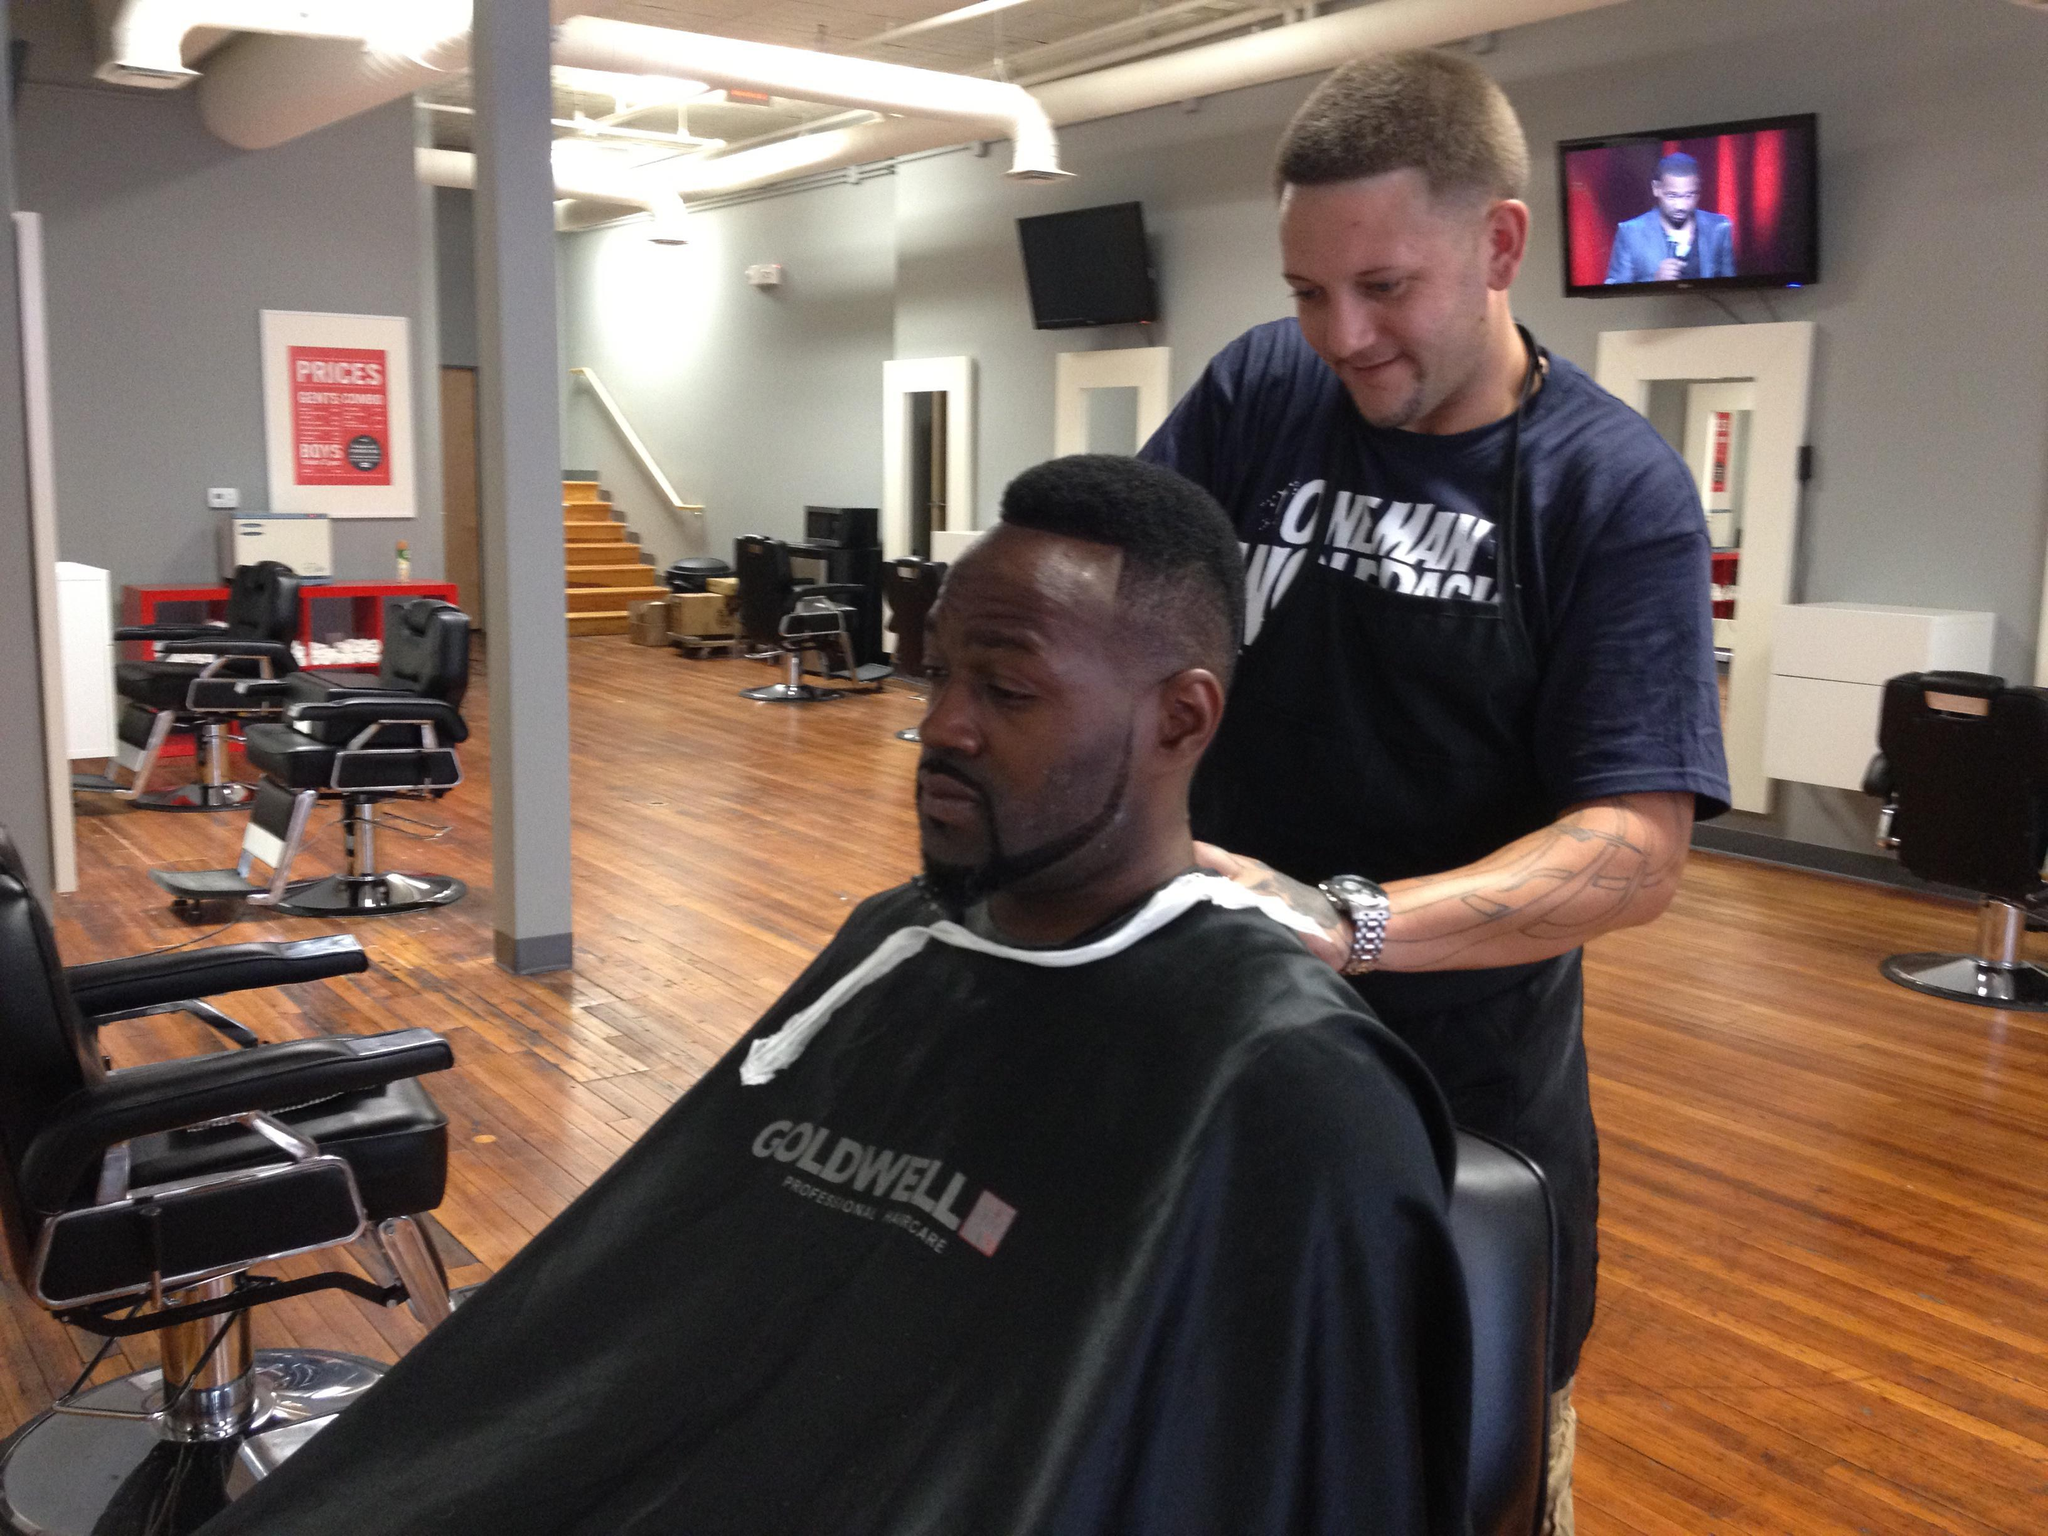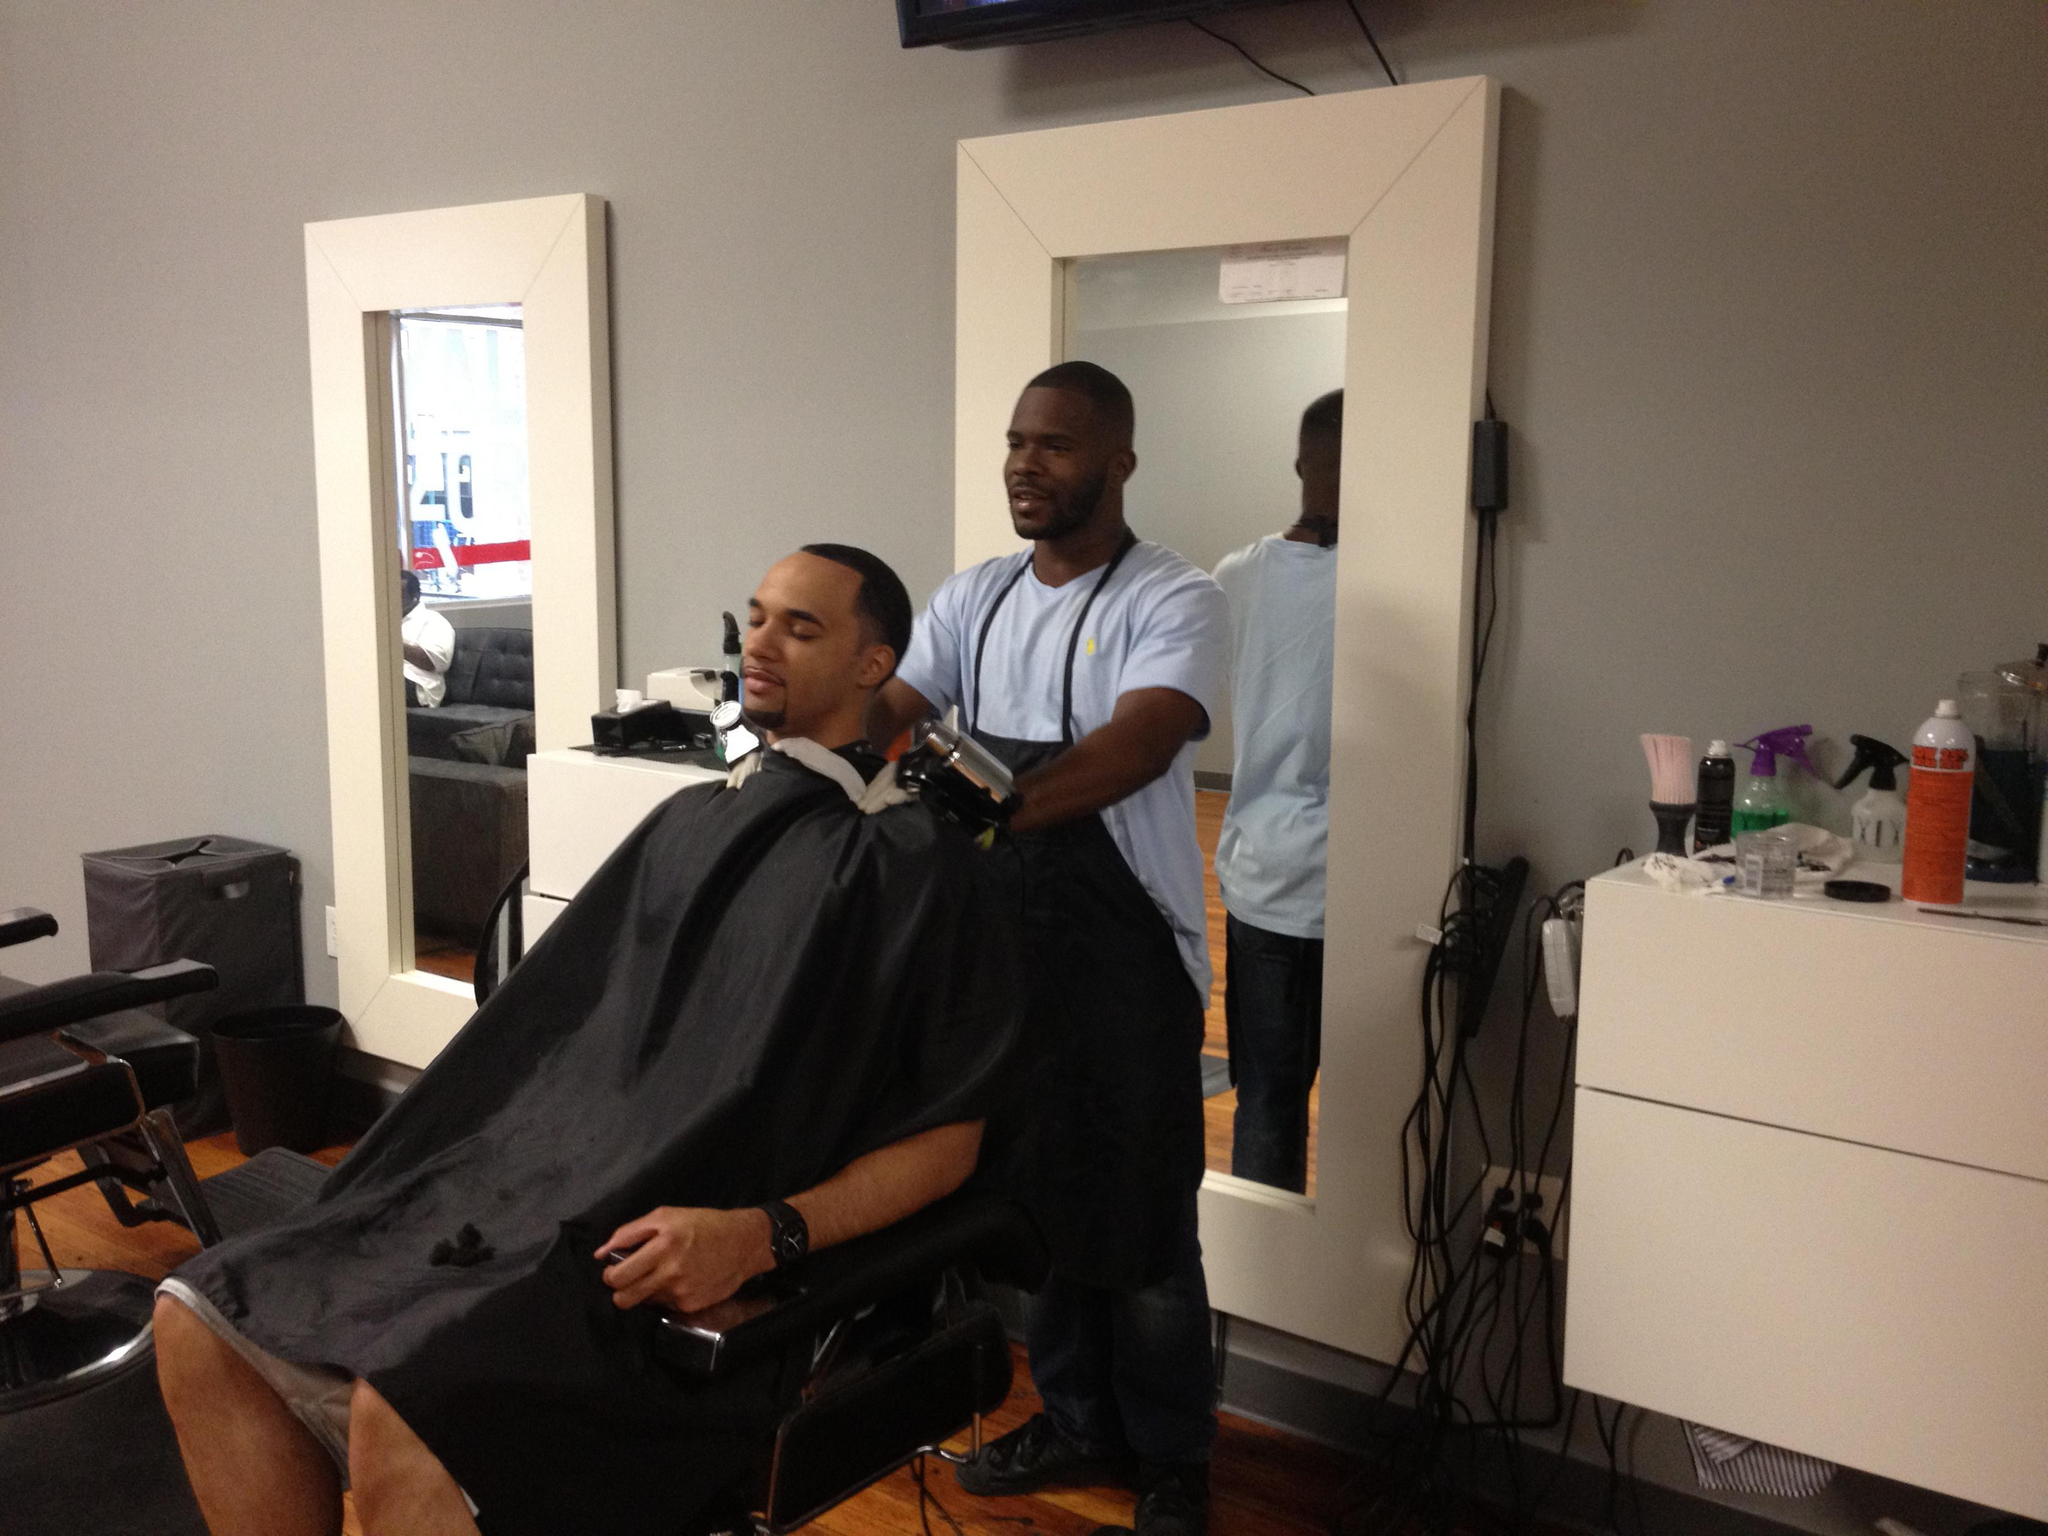The first image is the image on the left, the second image is the image on the right. Examine the images to the left and right. Is the description "There are exactly four people." accurate? Answer yes or no. Yes. The first image is the image on the left, the second image is the image on the right. Given the left and right images, does the statement "There are three barbers in total." hold true? Answer yes or no. No. 